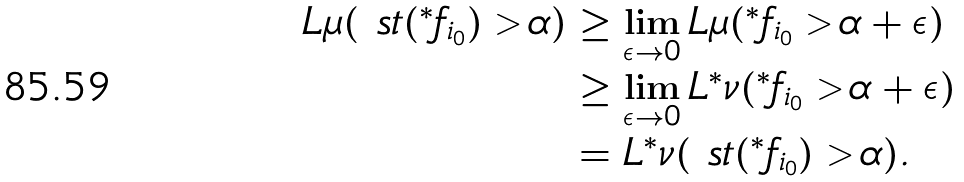Convert formula to latex. <formula><loc_0><loc_0><loc_500><loc_500>L \mu ( \ s t ( { ^ { * } } f _ { i _ { 0 } } ) > \alpha ) & \geq \lim _ { \epsilon \rightarrow 0 } L \mu ( { ^ { * } } f _ { i _ { 0 } } > \alpha + \epsilon ) \\ & \geq \lim _ { \epsilon \rightarrow 0 } L { ^ { * } } \nu ( { ^ { * } } f _ { i _ { 0 } } > \alpha + \epsilon ) \\ & = L { ^ { * } } \nu ( \ s t ( { ^ { * } } f _ { i _ { 0 } } ) > \alpha ) .</formula> 